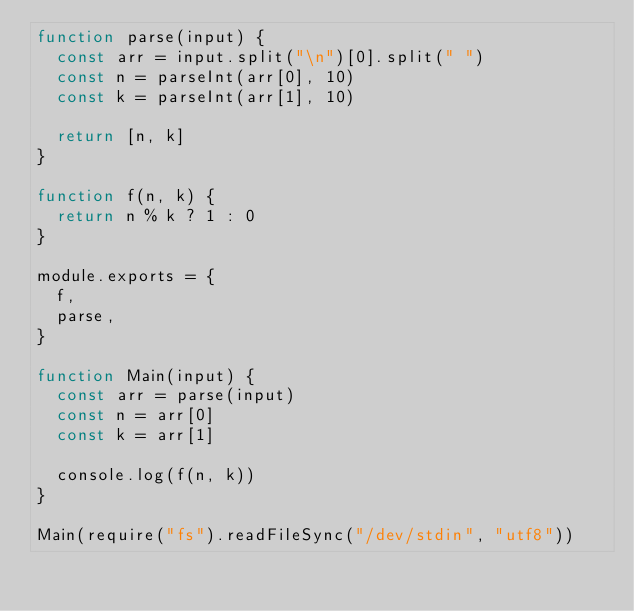<code> <loc_0><loc_0><loc_500><loc_500><_JavaScript_>function parse(input) {
  const arr = input.split("\n")[0].split(" ")
  const n = parseInt(arr[0], 10)
  const k = parseInt(arr[1], 10)

  return [n, k]
}

function f(n, k) {
  return n % k ? 1 : 0
}

module.exports = {
  f,
  parse,
}

function Main(input) {
  const arr = parse(input)
  const n = arr[0]
  const k = arr[1]

  console.log(f(n, k))
}

Main(require("fs").readFileSync("/dev/stdin", "utf8"))
</code> 